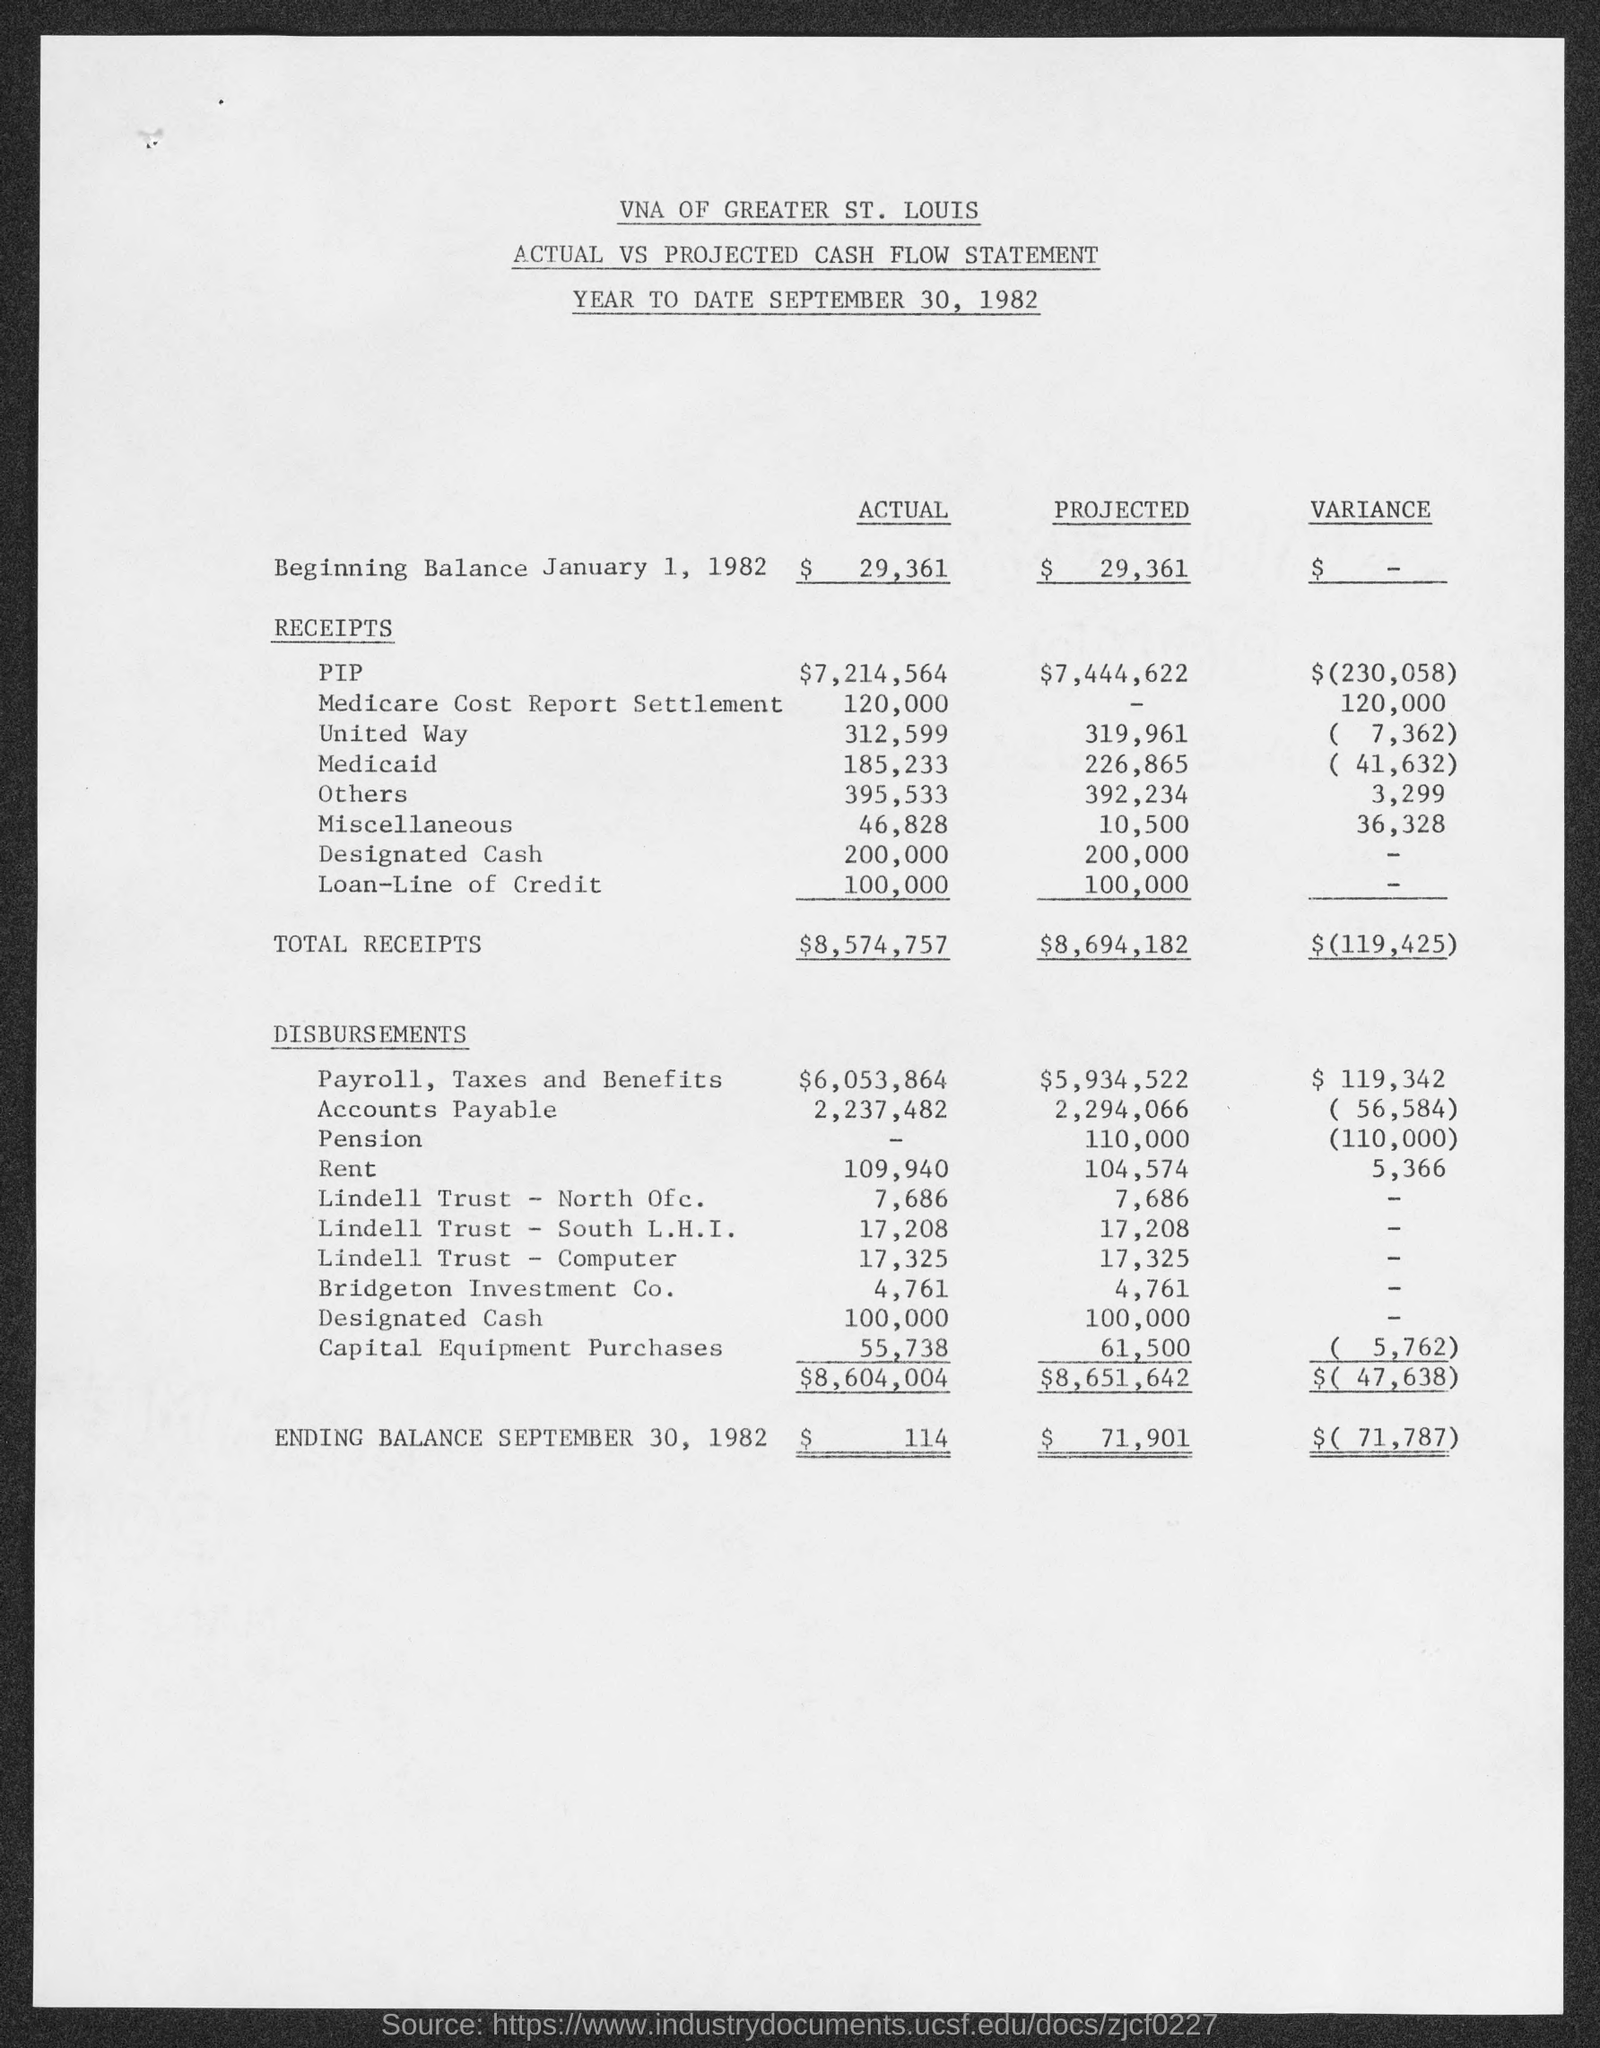How much is the actual pip?
Keep it short and to the point. $7,214,564. How much is the projected PIP?
Make the answer very short. $7,444,622. How much is the actual Medicare cost report settlement?
Provide a succinct answer. 120,000. How much is the actual United way?
Make the answer very short. 312,599. How much is the projected United Way?
Offer a terse response. 319,961. How much is the actual designated cash?
Your answer should be compact. 200,000. How much is the projected miscellaneous?
Ensure brevity in your answer.  10,500. What is the ending balance date?
Make the answer very short. September 30, 1982. What is the Begining balance date?
Give a very brief answer. January 1, 1982. 